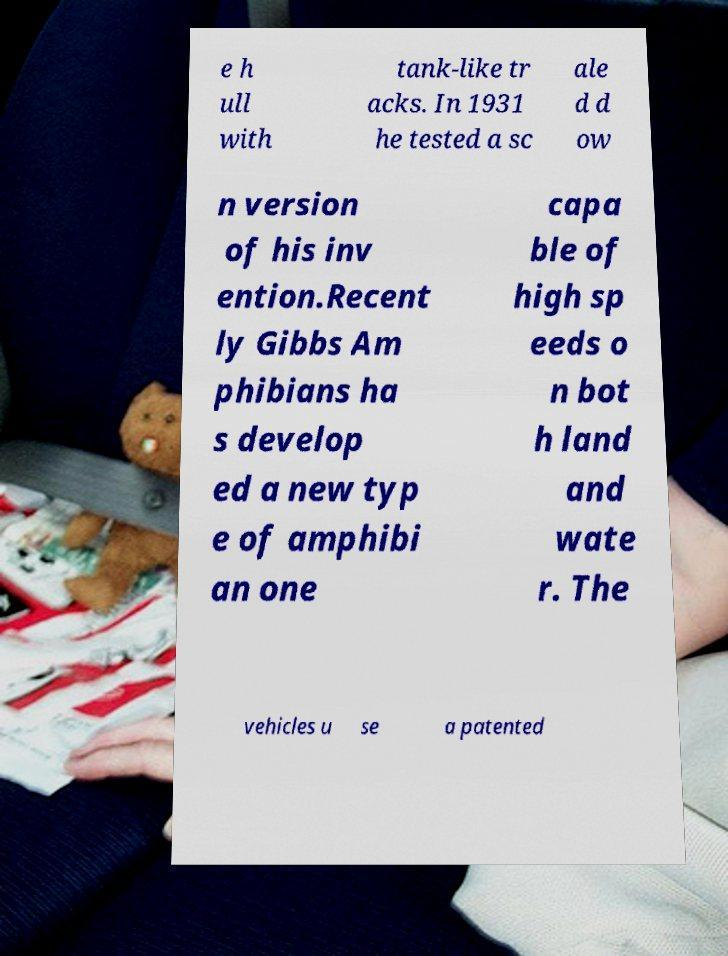I need the written content from this picture converted into text. Can you do that? e h ull with tank-like tr acks. In 1931 he tested a sc ale d d ow n version of his inv ention.Recent ly Gibbs Am phibians ha s develop ed a new typ e of amphibi an one capa ble of high sp eeds o n bot h land and wate r. The vehicles u se a patented 